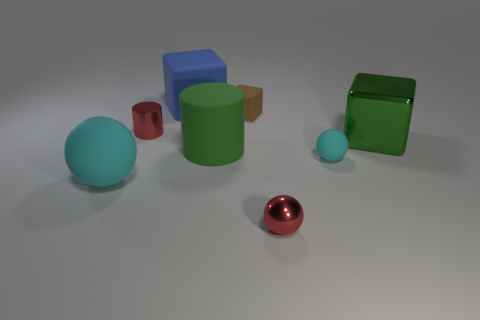Add 2 red shiny cylinders. How many objects exist? 10 Subtract all blocks. How many objects are left? 5 Subtract 2 cyan spheres. How many objects are left? 6 Subtract all small purple matte cubes. Subtract all tiny cylinders. How many objects are left? 7 Add 4 small rubber balls. How many small rubber balls are left? 5 Add 5 tiny purple metal cylinders. How many tiny purple metal cylinders exist? 5 